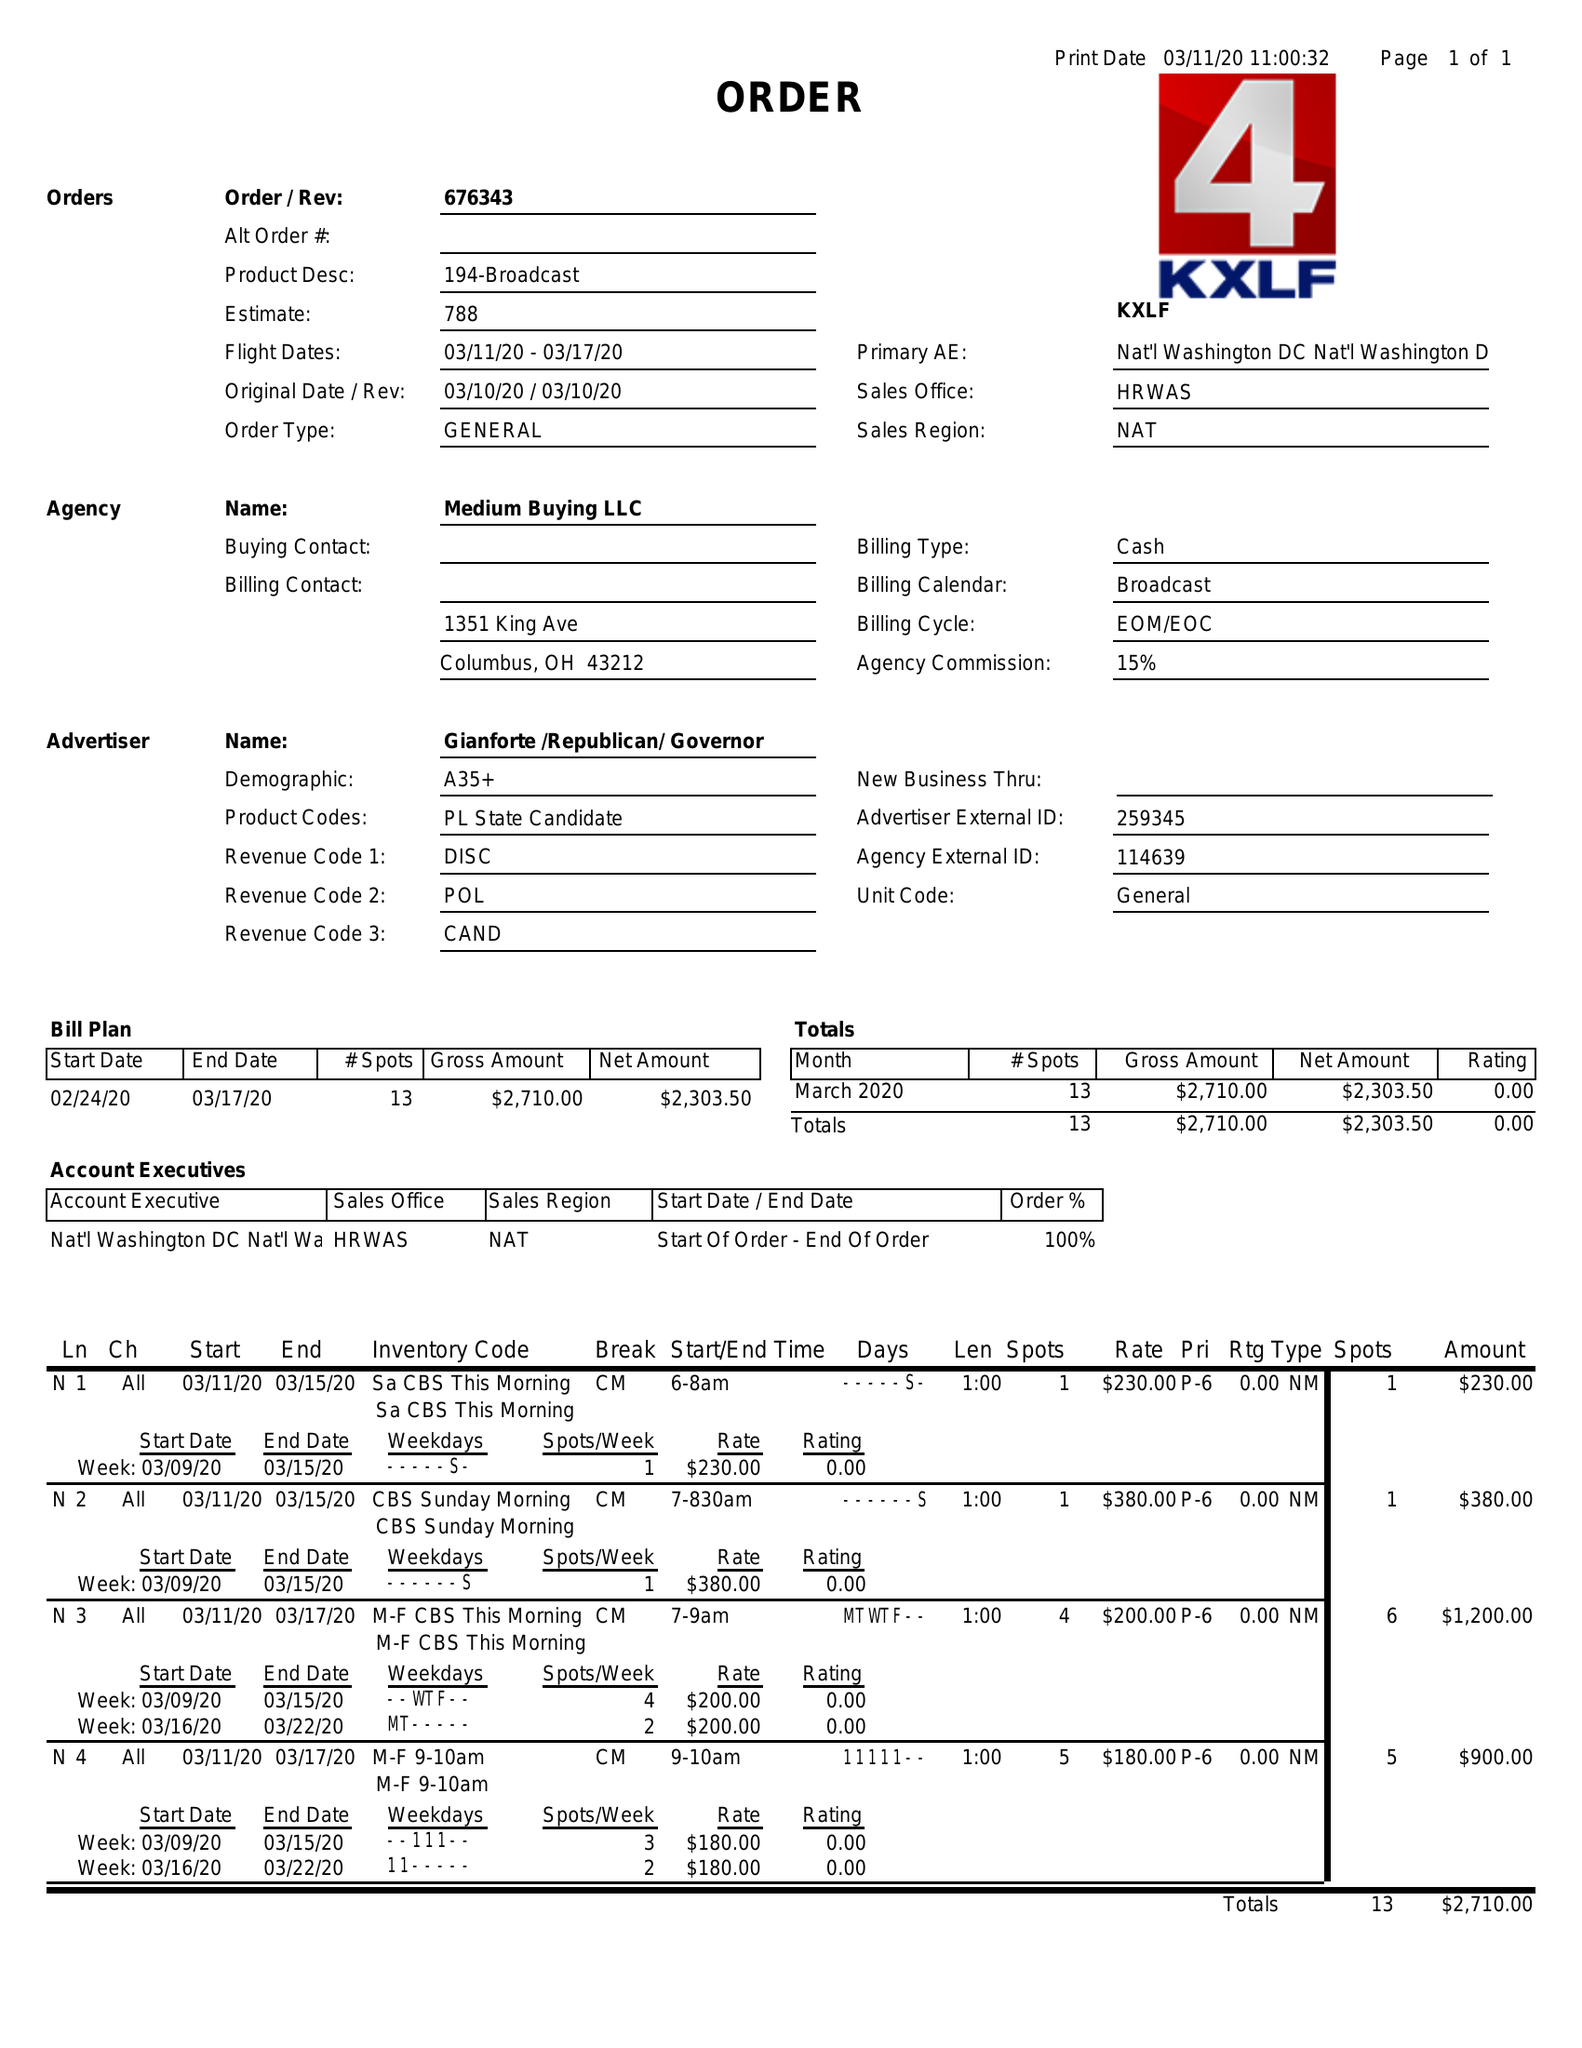What is the value for the flight_from?
Answer the question using a single word or phrase. 03/11/20 